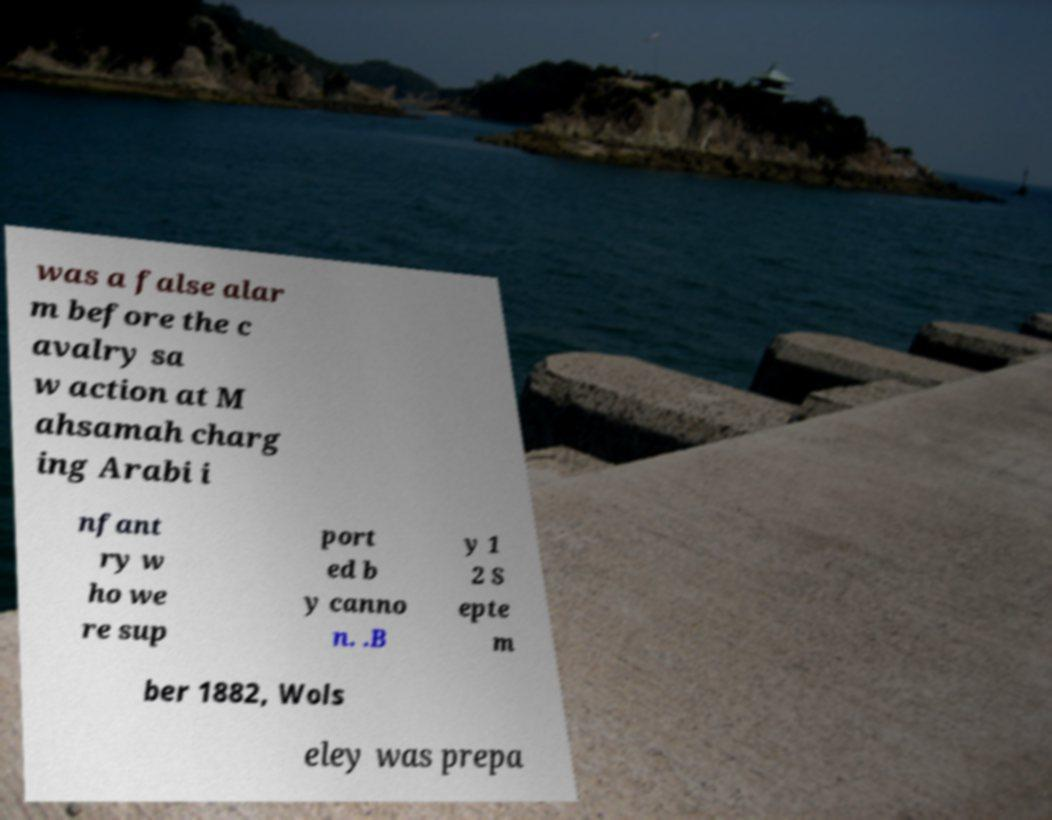Can you accurately transcribe the text from the provided image for me? was a false alar m before the c avalry sa w action at M ahsamah charg ing Arabi i nfant ry w ho we re sup port ed b y canno n. .B y 1 2 S epte m ber 1882, Wols eley was prepa 